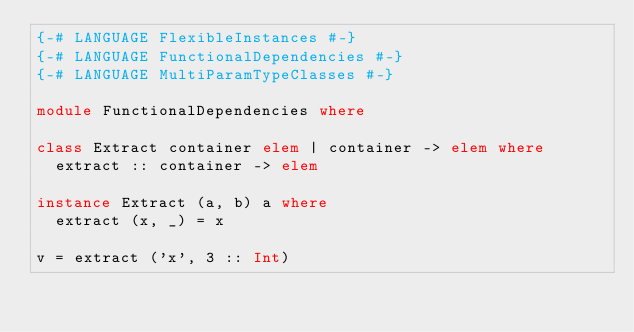Convert code to text. <code><loc_0><loc_0><loc_500><loc_500><_Haskell_>{-# LANGUAGE FlexibleInstances #-}
{-# LANGUAGE FunctionalDependencies #-}
{-# LANGUAGE MultiParamTypeClasses #-}

module FunctionalDependencies where

class Extract container elem | container -> elem where
  extract :: container -> elem

instance Extract (a, b) a where
  extract (x, _) = x

v = extract ('x', 3 :: Int)
</code> 